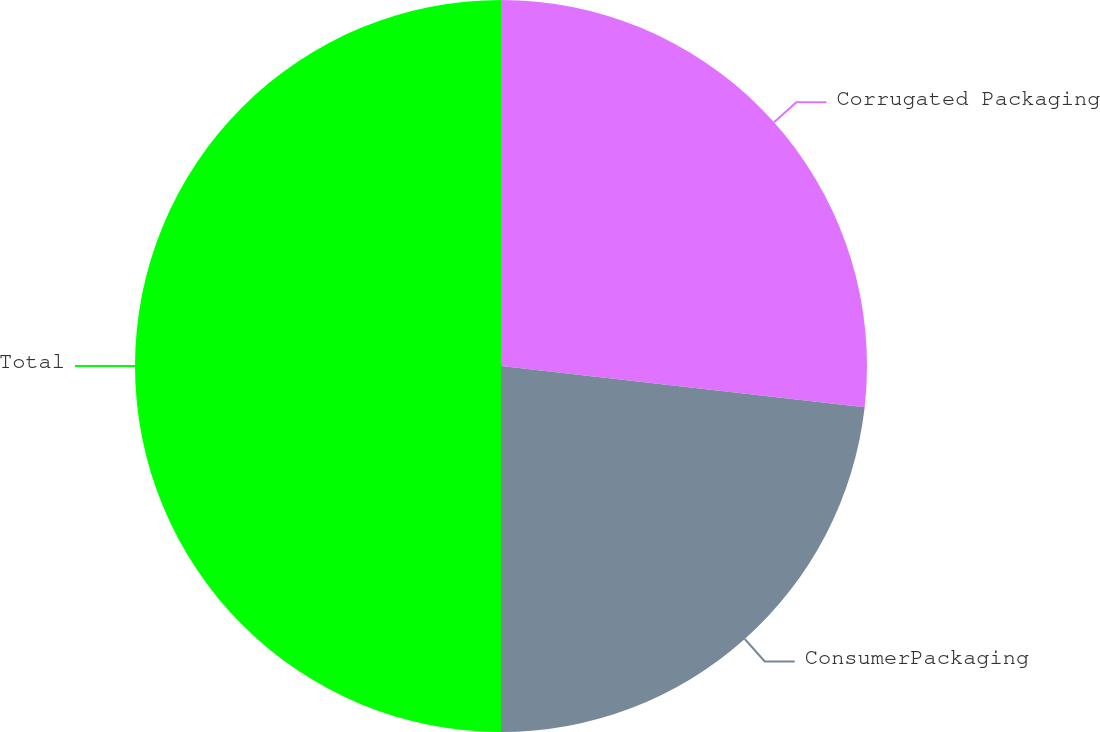Convert chart to OTSL. <chart><loc_0><loc_0><loc_500><loc_500><pie_chart><fcel>Corrugated Packaging<fcel>ConsumerPackaging<fcel>Total<nl><fcel>26.8%<fcel>23.2%<fcel>50.0%<nl></chart> 